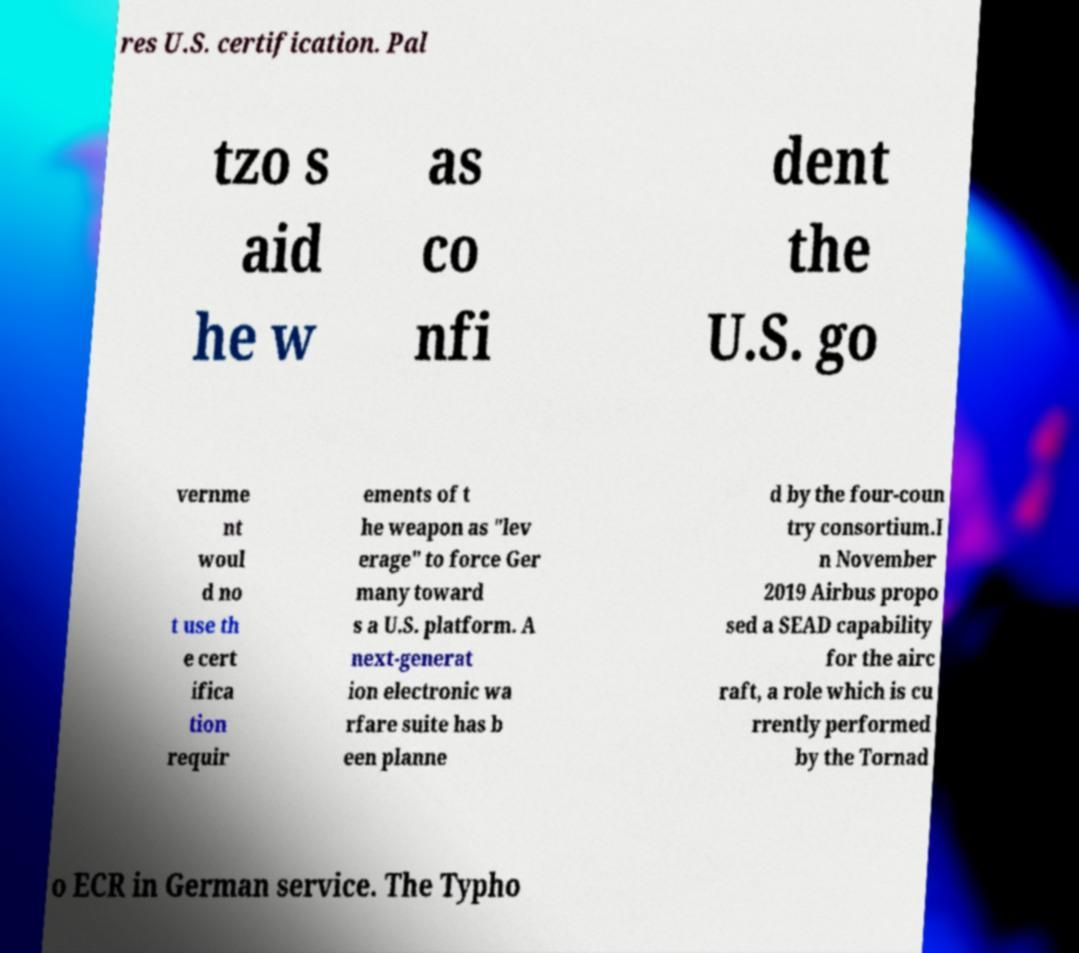Can you accurately transcribe the text from the provided image for me? res U.S. certification. Pal tzo s aid he w as co nfi dent the U.S. go vernme nt woul d no t use th e cert ifica tion requir ements of t he weapon as "lev erage" to force Ger many toward s a U.S. platform. A next-generat ion electronic wa rfare suite has b een planne d by the four-coun try consortium.I n November 2019 Airbus propo sed a SEAD capability for the airc raft, a role which is cu rrently performed by the Tornad o ECR in German service. The Typho 